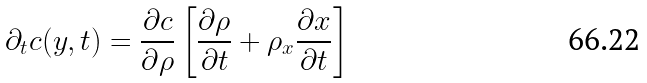<formula> <loc_0><loc_0><loc_500><loc_500>\partial _ { t } c ( y , t ) = \frac { \partial c } { \partial \rho } \left [ \frac { \partial \rho } { \partial t } + \rho _ { x } \frac { \partial x } { \partial t } \right ]</formula> 